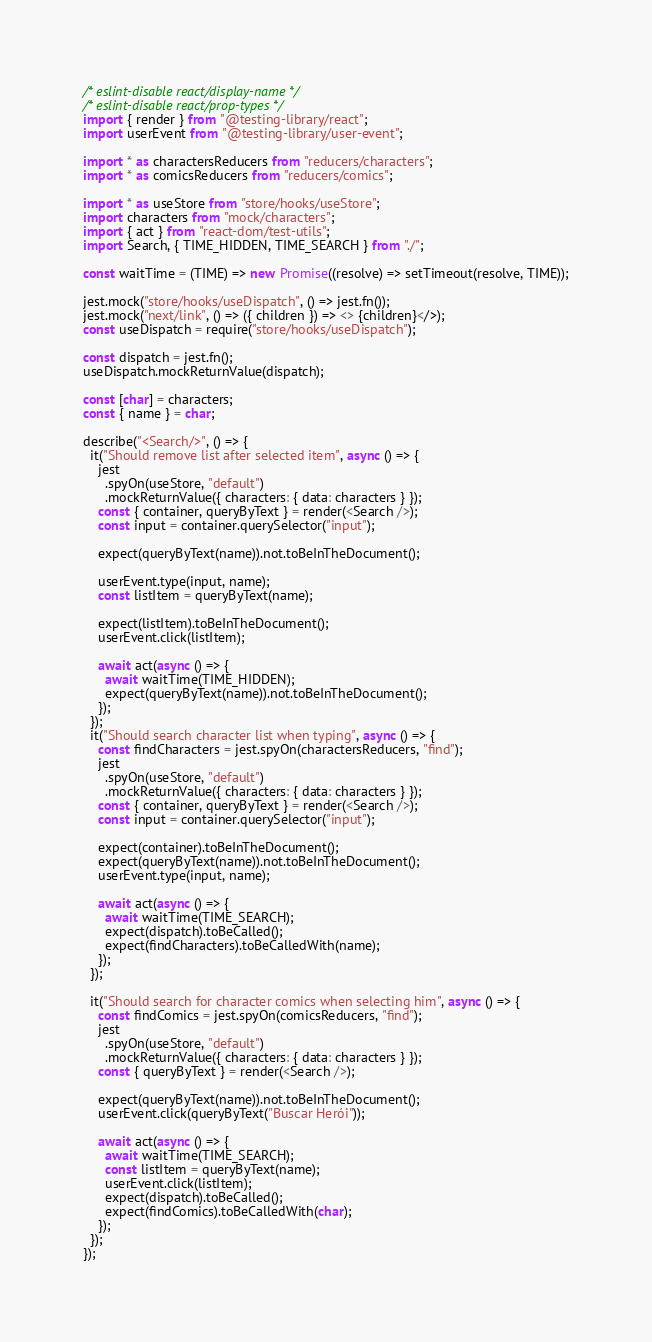<code> <loc_0><loc_0><loc_500><loc_500><_JavaScript_>/* eslint-disable react/display-name */
/* eslint-disable react/prop-types */
import { render } from "@testing-library/react";
import userEvent from "@testing-library/user-event";

import * as charactersReducers from "reducers/characters";
import * as comicsReducers from "reducers/comics";

import * as useStore from "store/hooks/useStore";
import characters from "mock/characters";
import { act } from "react-dom/test-utils";
import Search, { TIME_HIDDEN, TIME_SEARCH } from "./";

const waitTime = (TIME) => new Promise((resolve) => setTimeout(resolve, TIME));

jest.mock("store/hooks/useDispatch", () => jest.fn());
jest.mock("next/link", () => ({ children }) => <> {children}</>);
const useDispatch = require("store/hooks/useDispatch");

const dispatch = jest.fn();
useDispatch.mockReturnValue(dispatch);

const [char] = characters;
const { name } = char;

describe("<Search/>", () => {
  it("Should remove list after selected item", async () => {
    jest
      .spyOn(useStore, "default")
      .mockReturnValue({ characters: { data: characters } });
    const { container, queryByText } = render(<Search />);
    const input = container.querySelector("input");

    expect(queryByText(name)).not.toBeInTheDocument();

    userEvent.type(input, name);
    const listItem = queryByText(name);

    expect(listItem).toBeInTheDocument();
    userEvent.click(listItem);

    await act(async () => {
      await waitTime(TIME_HIDDEN);
      expect(queryByText(name)).not.toBeInTheDocument();
    });
  });
  it("Should search character list when typing", async () => {
    const findCharacters = jest.spyOn(charactersReducers, "find");
    jest
      .spyOn(useStore, "default")
      .mockReturnValue({ characters: { data: characters } });
    const { container, queryByText } = render(<Search />);
    const input = container.querySelector("input");

    expect(container).toBeInTheDocument();
    expect(queryByText(name)).not.toBeInTheDocument();
    userEvent.type(input, name);

    await act(async () => {
      await waitTime(TIME_SEARCH);
      expect(dispatch).toBeCalled();
      expect(findCharacters).toBeCalledWith(name);
    });
  });

  it("Should search for character comics when selecting him", async () => {
    const findComics = jest.spyOn(comicsReducers, "find");
    jest
      .spyOn(useStore, "default")
      .mockReturnValue({ characters: { data: characters } });
    const { queryByText } = render(<Search />);

    expect(queryByText(name)).not.toBeInTheDocument();
    userEvent.click(queryByText("Buscar Herói"));

    await act(async () => {
      await waitTime(TIME_SEARCH);
      const listItem = queryByText(name);
      userEvent.click(listItem);
      expect(dispatch).toBeCalled();
      expect(findComics).toBeCalledWith(char);
    });
  });
});
</code> 